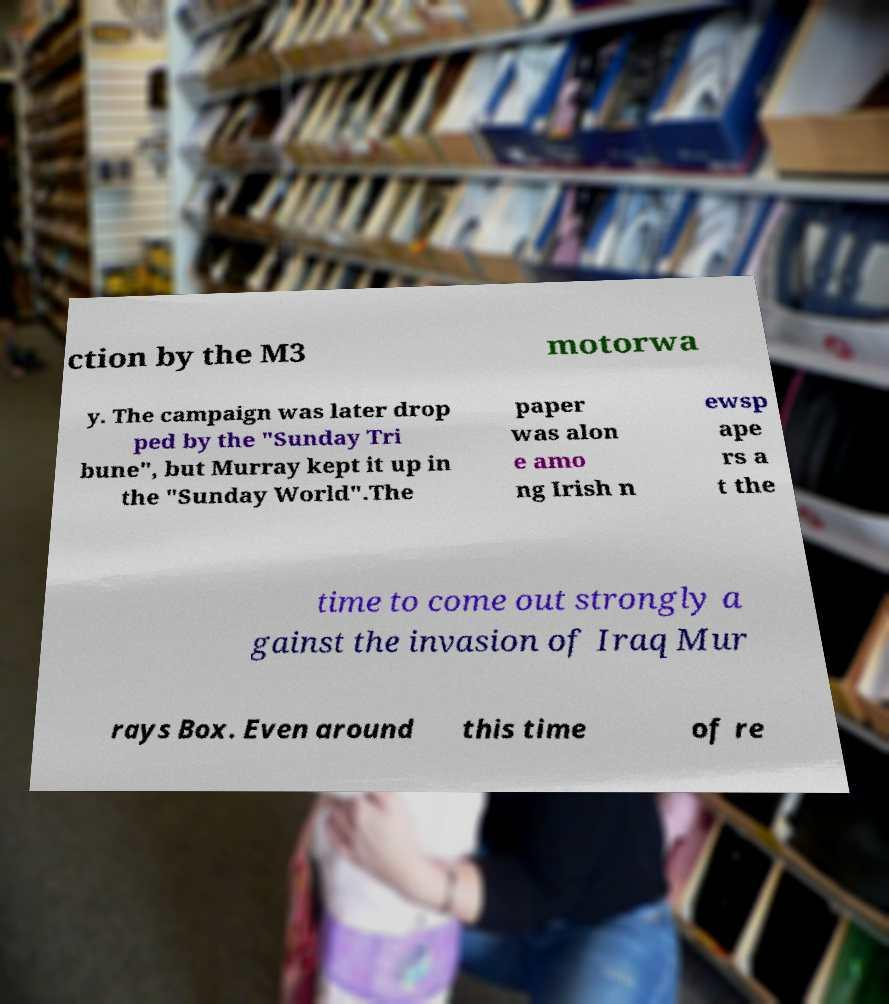Can you read and provide the text displayed in the image?This photo seems to have some interesting text. Can you extract and type it out for me? ction by the M3 motorwa y. The campaign was later drop ped by the "Sunday Tri bune", but Murray kept it up in the "Sunday World".The paper was alon e amo ng Irish n ewsp ape rs a t the time to come out strongly a gainst the invasion of Iraq Mur rays Box. Even around this time of re 